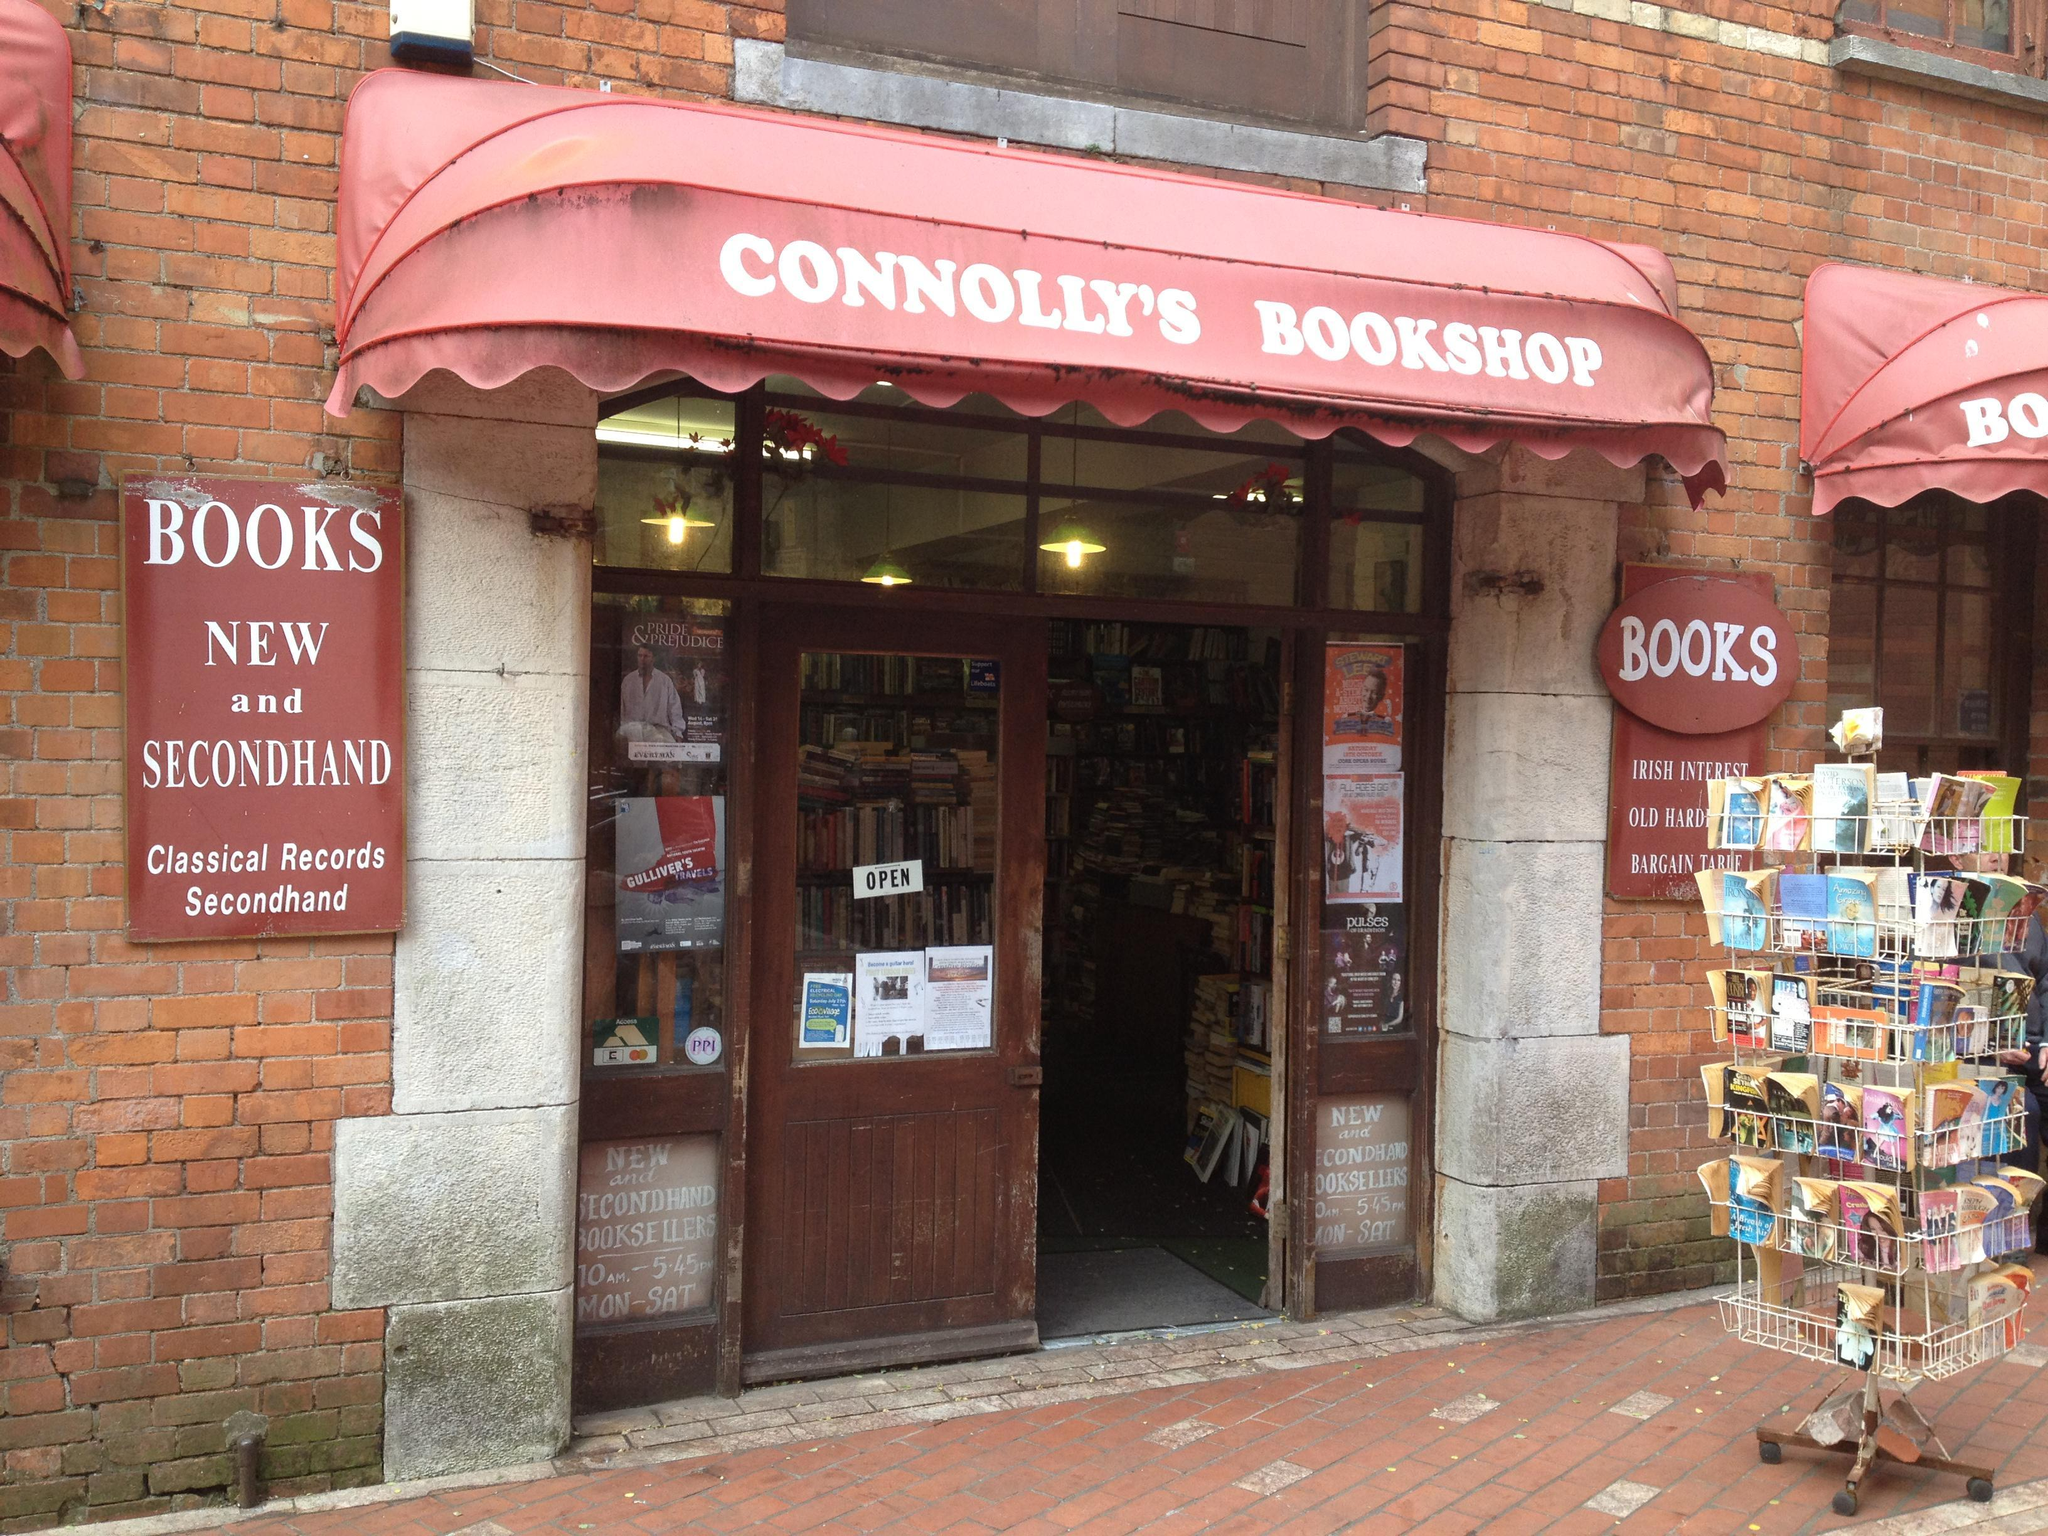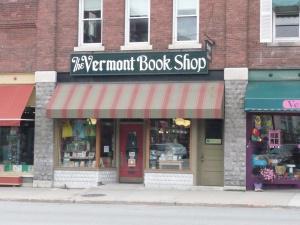The first image is the image on the left, the second image is the image on the right. For the images shown, is this caption "A bookstore exterior has the store name on an awning over a double door and has a display stand of books outside the doors." true? Answer yes or no. Yes. 